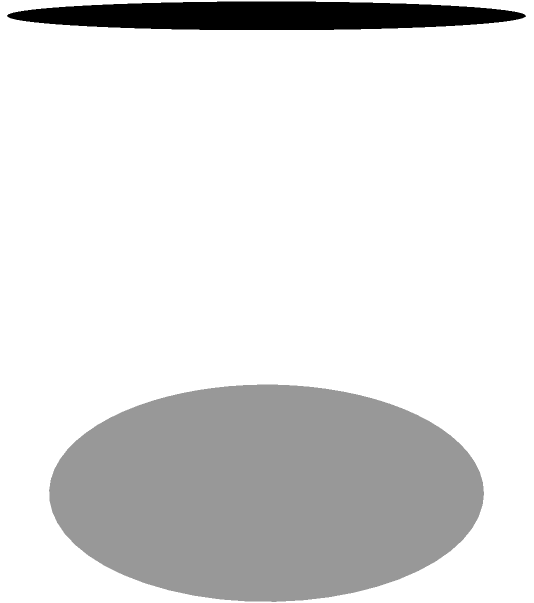As a PR agent for a renowned pastry chef, you're planning to feature their signature cylindrical cake in a food blogger's post. The cake has a radius of 6 inches and a height of 10 inches. To accurately describe the cake's impressive size, you need to calculate its volume. What is the volume of the cylindrical cake in cubic inches? To calculate the volume of a cylindrical cake, we need to use the formula for the volume of a cylinder:

$$V = \pi r^2 h$$

Where:
$V$ = volume
$\pi$ = pi (approximately 3.14159)
$r$ = radius of the base
$h$ = height of the cylinder

Given:
- Radius ($r$) = 6 inches
- Height ($h$) = 10 inches

Let's substitute these values into the formula:

$$V = \pi (6^2) (10)$$

Now, let's calculate step by step:

1) First, calculate $6^2$:
   $$6^2 = 36$$

2) Multiply by $\pi$:
   $$\pi (36) \approx 113.097$$

3) Multiply by the height (10):
   $$113.097 * 10 \approx 1130.97$$

Therefore, the volume of the cylindrical cake is approximately 1130.97 cubic inches.

For PR purposes, you might want to round this to 1,131 cubic inches to make it easier to communicate.
Answer: 1,131 cubic inches 